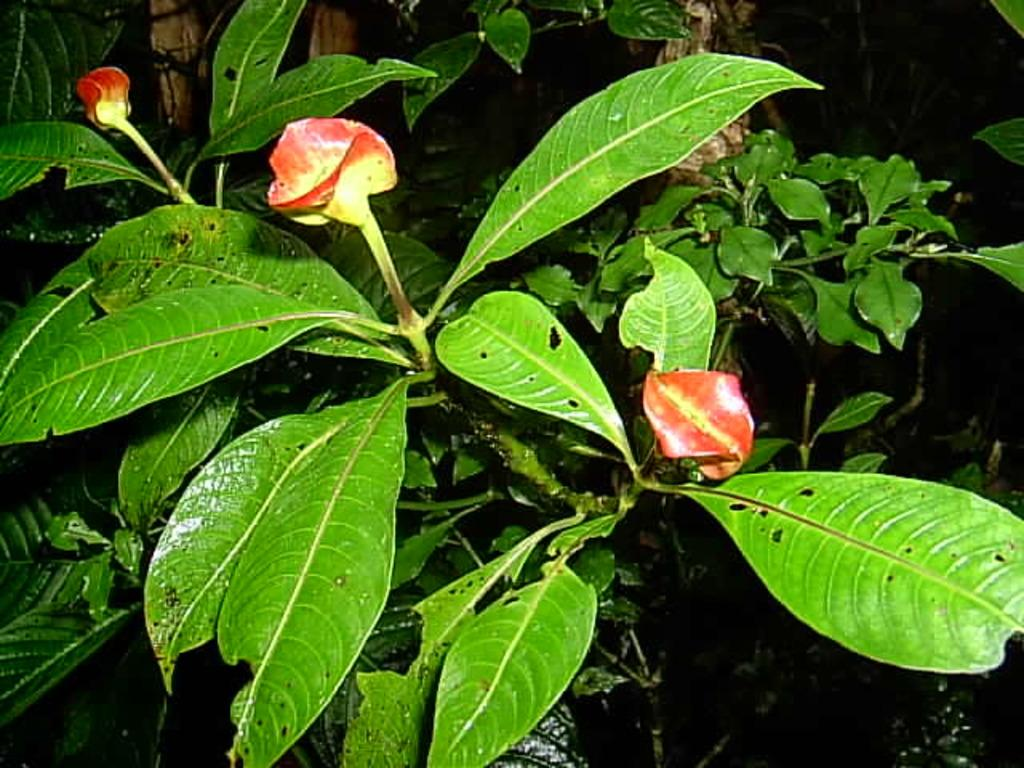Where was the image taken? The image was taken outdoors. What can be seen in the image besides the outdoor setting? There are plants and three red flowers in the image. What organization is responsible for the beggar in the image? There is no beggar present in the image. 